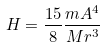Convert formula to latex. <formula><loc_0><loc_0><loc_500><loc_500>H = { \frac { 1 5 } { 8 } } { \frac { m A ^ { 4 } } { M r ^ { 3 } } }</formula> 